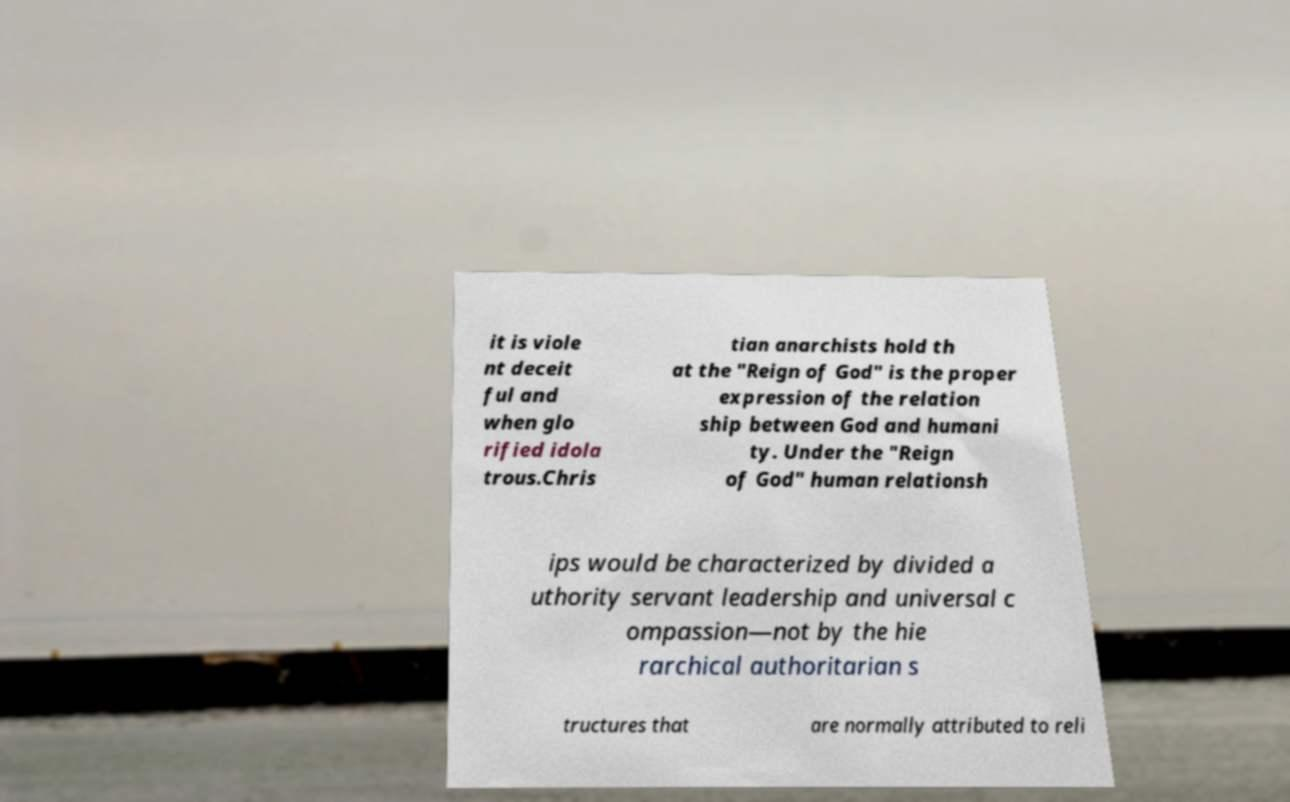Could you assist in decoding the text presented in this image and type it out clearly? it is viole nt deceit ful and when glo rified idola trous.Chris tian anarchists hold th at the "Reign of God" is the proper expression of the relation ship between God and humani ty. Under the "Reign of God" human relationsh ips would be characterized by divided a uthority servant leadership and universal c ompassion—not by the hie rarchical authoritarian s tructures that are normally attributed to reli 